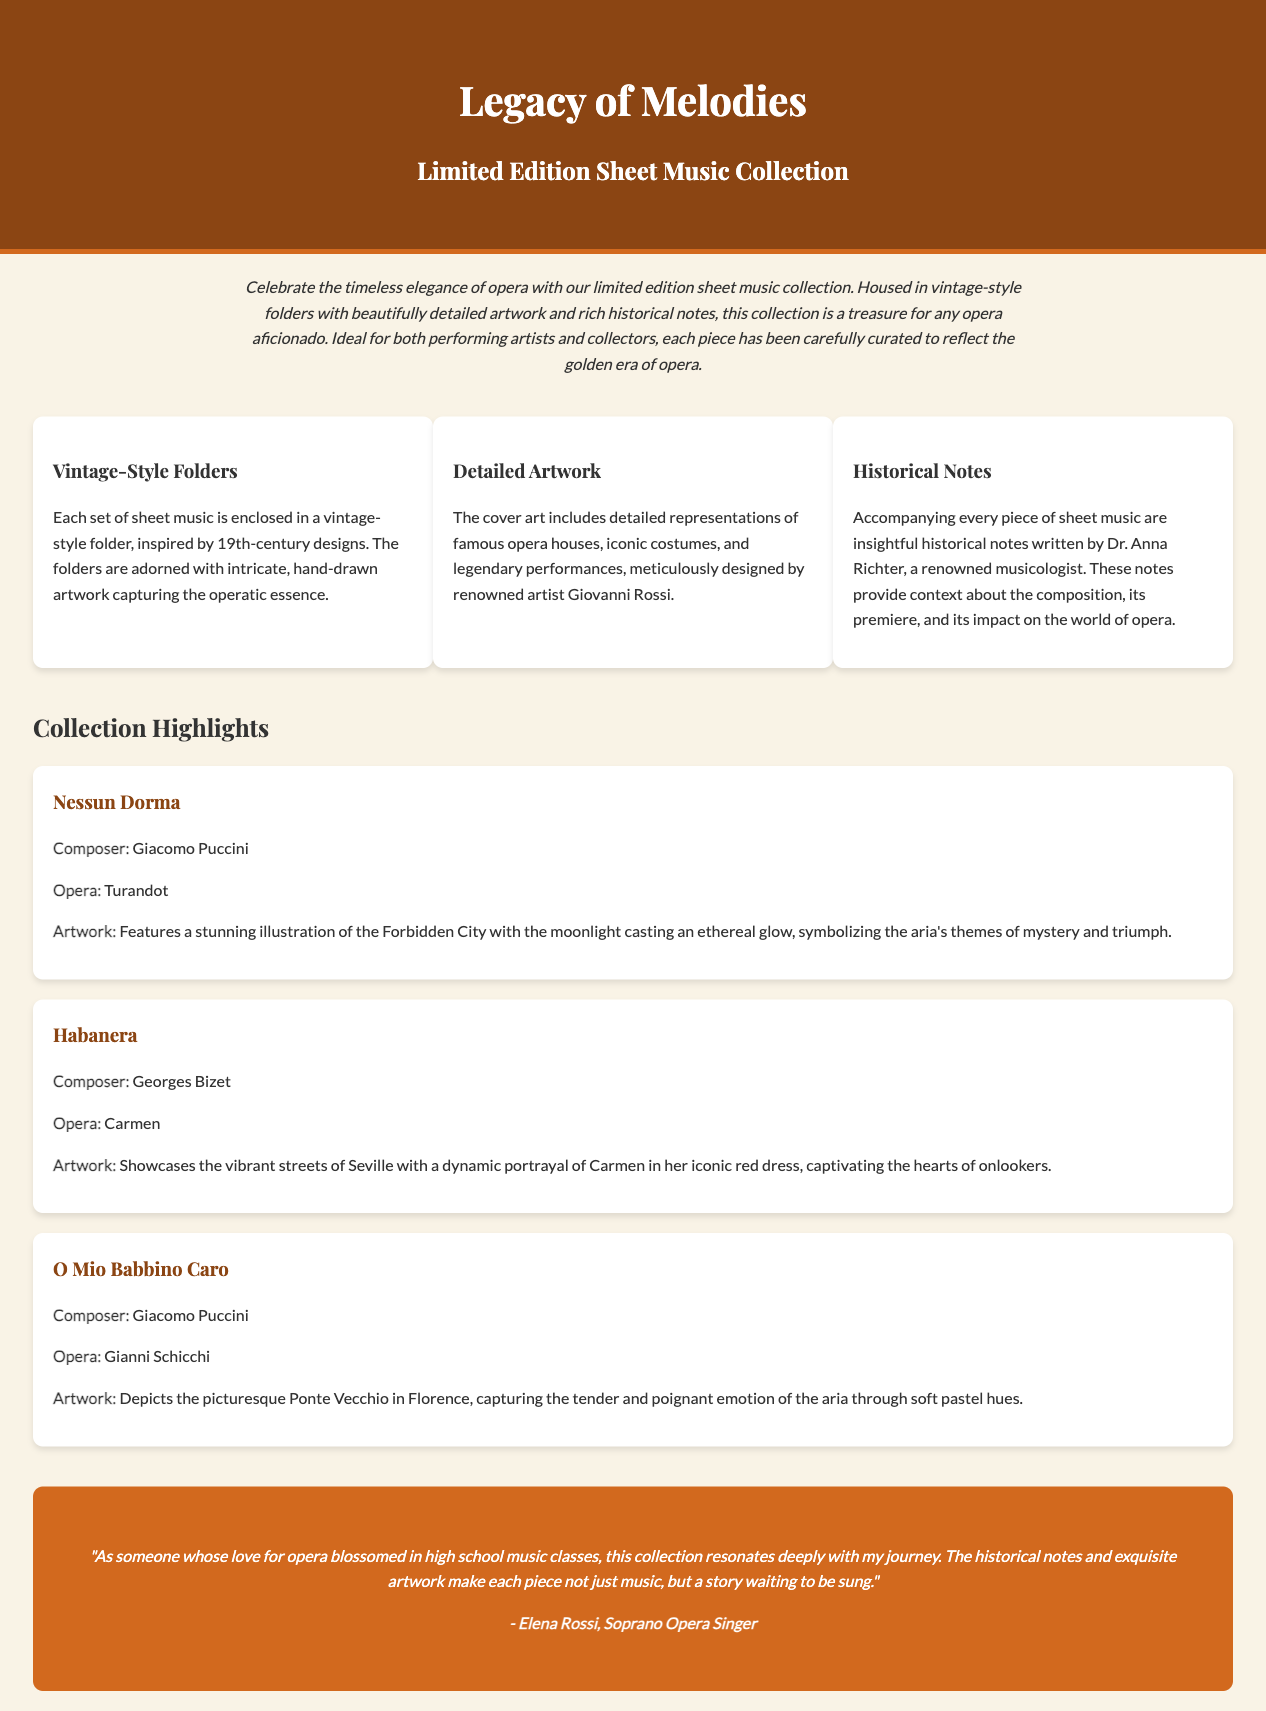what is the title of the collection? The title of the collection is found in the header of the document, prominently displayed.
Answer: Legacy of Melodies who is the artist behind the detailed artwork? The artist responsible for the artwork is mentioned in the features section, specifically related to the cover art.
Answer: Giovanni Rossi what is included with each piece of sheet music? The document states there are insights provided with each piece, requiring knowledge of its content for the answer.
Answer: Historical notes which opera features the aria "Nessun Dorma"? The opera associated with "Nessun Dorma" is listed under the collection highlights along with the composer.
Answer: Turandot how many collection highlights are there? The number of highlights can be counted within the collection highlights section as they are presented in individual segments.
Answer: Three who wrote the historical notes? The author of the historical notes is specifically mentioned in the features section of the document.
Answer: Dr. Anna Richter what theme is symbolized in the artwork for "O Mio Babbino Caro"? The artwork's description indicates the themes it represents, focusing on emotional expression in “O Mio Babbino Caro.”
Answer: Tender and poignant emotion what type of folders is the music collection housed in? The type of folders used for the collection is described in the features section concerning their design and inspiration.
Answer: Vintage-style folders where is the illustration for "Habanera" set? The setting of the illustration for the aria "Habanera" is given in the highlights section regarding its artwork.
Answer: Seville 